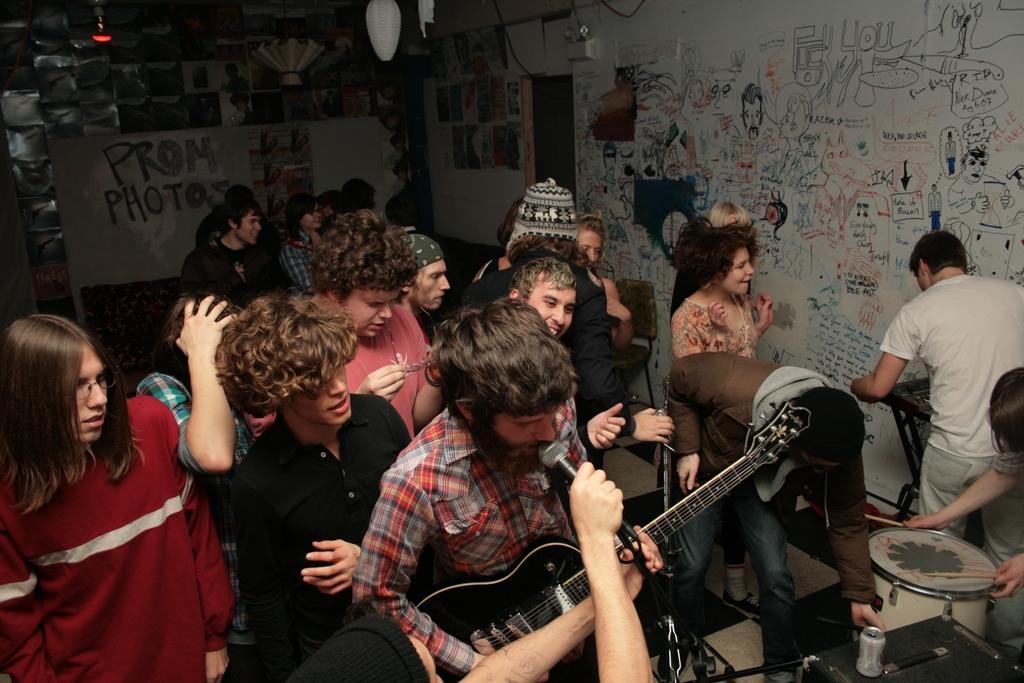Describe this image in one or two sentences. There are some people in the room, one of the guy is holding a microphone in front of the another guy, who is holding a guitar. There are men and women in this room and some drums here. In the background there is a wall on which some crayons were scribbled here. 